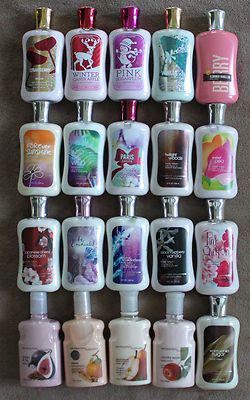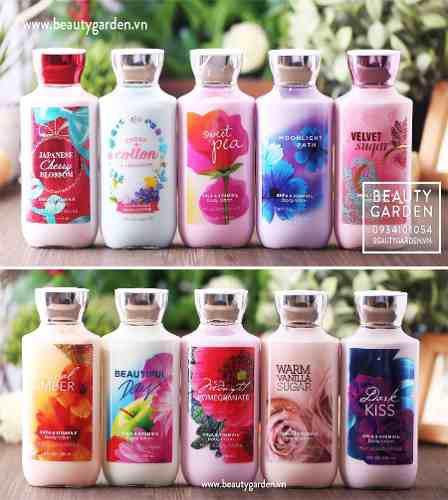The first image is the image on the left, the second image is the image on the right. Assess this claim about the two images: "There are exactly three products in one of the images.". Correct or not? Answer yes or no. No. The first image is the image on the left, the second image is the image on the right. Assess this claim about the two images: "One of the images has exactly three bottles.". Correct or not? Answer yes or no. No. 